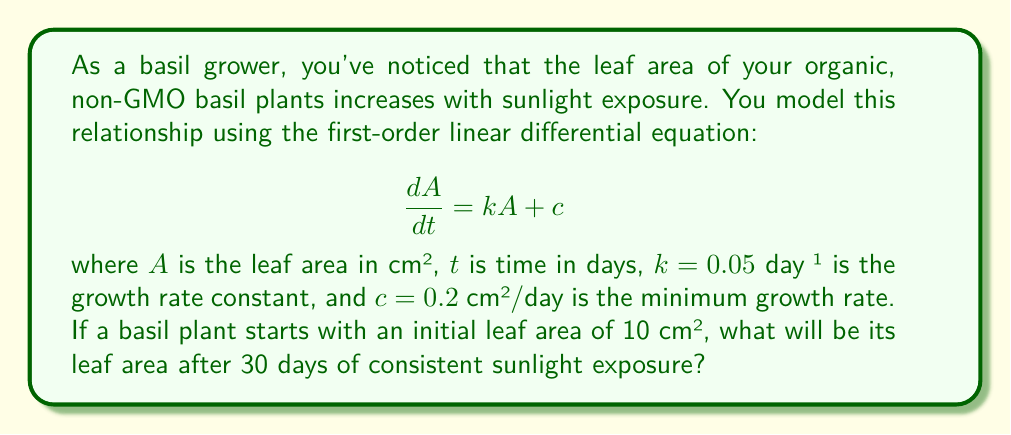Solve this math problem. To solve this first-order linear differential equation, we follow these steps:

1) The general solution for this type of equation is:

   $$A(t) = Ce^{kt} - \frac{c}{k}$$

   where $C$ is a constant we need to determine.

2) We use the initial condition to find $C$:
   At $t = 0$, $A = 10$ cm²

   $$10 = Ce^{0} - \frac{0.2}{0.05}$$
   $$10 = C - 4$$
   $$C = 14$$

3) Now we have the particular solution:

   $$A(t) = 14e^{0.05t} - 4$$

4) To find the leaf area after 30 days, we substitute $t = 30$:

   $$A(30) = 14e^{0.05(30)} - 4$$
   $$A(30) = 14e^{1.5} - 4$$
   $$A(30) = 14(4.4817) - 4$$
   $$A(30) = 62.7438 - 4$$
   $$A(30) = 58.7438$$

5) Rounding to two decimal places:

   $$A(30) \approx 58.74 \text{ cm²}$$
Answer: After 30 days of consistent sunlight exposure, the basil plant's leaf area will be approximately 58.74 cm². 